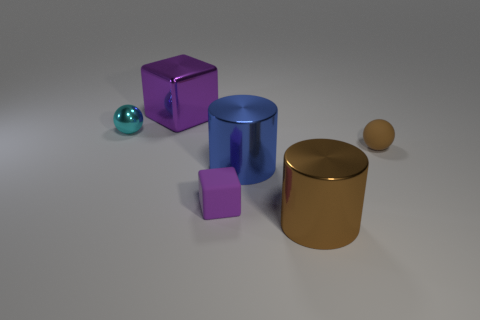Add 3 large blue matte blocks. How many objects exist? 9 Subtract all blocks. How many objects are left? 4 Add 5 small purple cubes. How many small purple cubes are left? 6 Add 1 metal blocks. How many metal blocks exist? 2 Subtract 0 cyan cylinders. How many objects are left? 6 Subtract all green shiny objects. Subtract all cyan metal things. How many objects are left? 5 